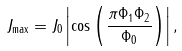Convert formula to latex. <formula><loc_0><loc_0><loc_500><loc_500>J _ { \max } = J _ { 0 } \left | \cos \left ( \frac { \pi \Phi _ { 1 } \Phi _ { 2 } } { \Phi _ { 0 } } \right ) \right | ,</formula> 